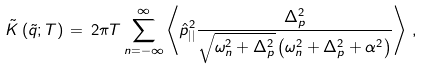<formula> <loc_0><loc_0><loc_500><loc_500>\tilde { K } \left ( \tilde { q } ; T \right ) \, = \, 2 \pi T \sum _ { n = - \infty } ^ { \infty } \left \langle \hat { p } _ { | | } ^ { 2 } \frac { \Delta _ { p } ^ { 2 } } { \sqrt { \omega _ { n } ^ { 2 } + \Delta _ { p } ^ { 2 } } \left ( \omega _ { n } ^ { 2 } + \Delta _ { p } ^ { 2 } + \alpha ^ { 2 } \right ) } \right \rangle \, ,</formula> 